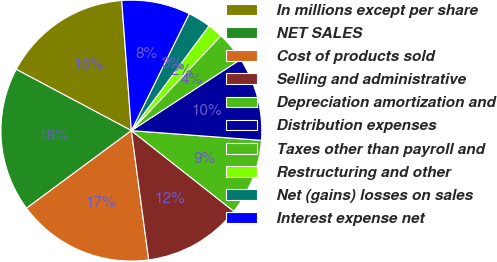Convert chart. <chart><loc_0><loc_0><loc_500><loc_500><pie_chart><fcel>In millions except per share<fcel>NET SALES<fcel>Cost of products sold<fcel>Selling and administrative<fcel>Depreciation amortization and<fcel>Distribution expenses<fcel>Taxes other than payroll and<fcel>Restructuring and other<fcel>Net (gains) losses on sales<fcel>Interest expense net<nl><fcel>16.04%<fcel>17.92%<fcel>16.98%<fcel>12.26%<fcel>9.43%<fcel>10.38%<fcel>3.77%<fcel>1.89%<fcel>2.83%<fcel>8.49%<nl></chart> 